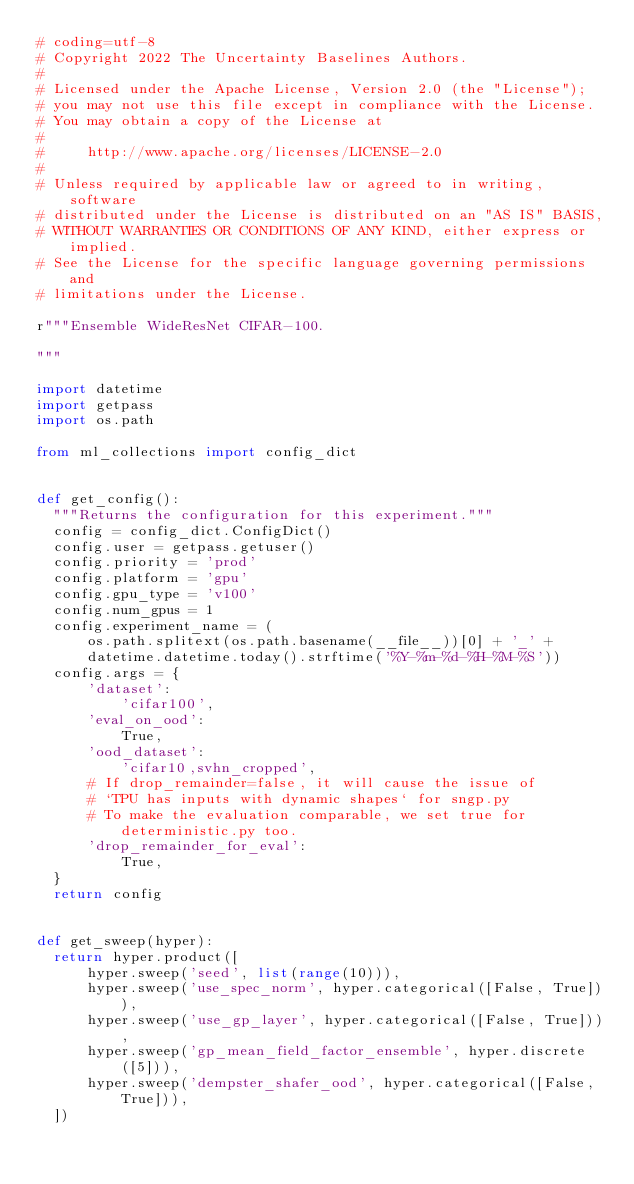<code> <loc_0><loc_0><loc_500><loc_500><_Python_># coding=utf-8
# Copyright 2022 The Uncertainty Baselines Authors.
#
# Licensed under the Apache License, Version 2.0 (the "License");
# you may not use this file except in compliance with the License.
# You may obtain a copy of the License at
#
#     http://www.apache.org/licenses/LICENSE-2.0
#
# Unless required by applicable law or agreed to in writing, software
# distributed under the License is distributed on an "AS IS" BASIS,
# WITHOUT WARRANTIES OR CONDITIONS OF ANY KIND, either express or implied.
# See the License for the specific language governing permissions and
# limitations under the License.

r"""Ensemble WideResNet CIFAR-100.

"""

import datetime
import getpass
import os.path

from ml_collections import config_dict


def get_config():
  """Returns the configuration for this experiment."""
  config = config_dict.ConfigDict()
  config.user = getpass.getuser()
  config.priority = 'prod'
  config.platform = 'gpu'
  config.gpu_type = 'v100'
  config.num_gpus = 1
  config.experiment_name = (
      os.path.splitext(os.path.basename(__file__))[0] + '_' +
      datetime.datetime.today().strftime('%Y-%m-%d-%H-%M-%S'))
  config.args = {
      'dataset':
          'cifar100',
      'eval_on_ood':
          True,
      'ood_dataset':
          'cifar10,svhn_cropped',
      # If drop_remainder=false, it will cause the issue of
      # `TPU has inputs with dynamic shapes` for sngp.py
      # To make the evaluation comparable, we set true for deterministic.py too.
      'drop_remainder_for_eval':
          True,
  }
  return config


def get_sweep(hyper):
  return hyper.product([
      hyper.sweep('seed', list(range(10))),
      hyper.sweep('use_spec_norm', hyper.categorical([False, True])),
      hyper.sweep('use_gp_layer', hyper.categorical([False, True])),
      hyper.sweep('gp_mean_field_factor_ensemble', hyper.discrete([5])),
      hyper.sweep('dempster_shafer_ood', hyper.categorical([False, True])),
  ])
</code> 